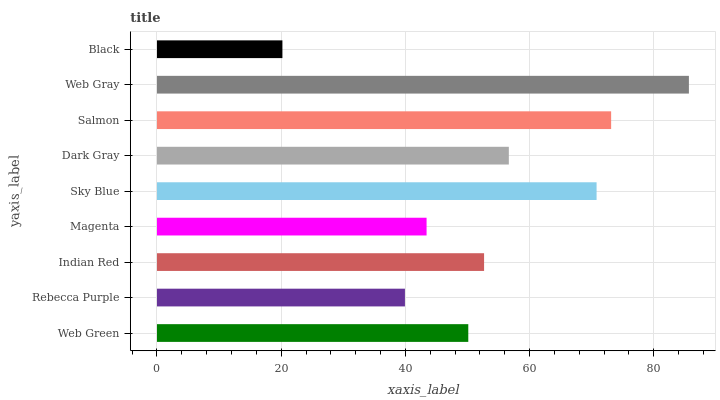Is Black the minimum?
Answer yes or no. Yes. Is Web Gray the maximum?
Answer yes or no. Yes. Is Rebecca Purple the minimum?
Answer yes or no. No. Is Rebecca Purple the maximum?
Answer yes or no. No. Is Web Green greater than Rebecca Purple?
Answer yes or no. Yes. Is Rebecca Purple less than Web Green?
Answer yes or no. Yes. Is Rebecca Purple greater than Web Green?
Answer yes or no. No. Is Web Green less than Rebecca Purple?
Answer yes or no. No. Is Indian Red the high median?
Answer yes or no. Yes. Is Indian Red the low median?
Answer yes or no. Yes. Is Web Green the high median?
Answer yes or no. No. Is Web Green the low median?
Answer yes or no. No. 